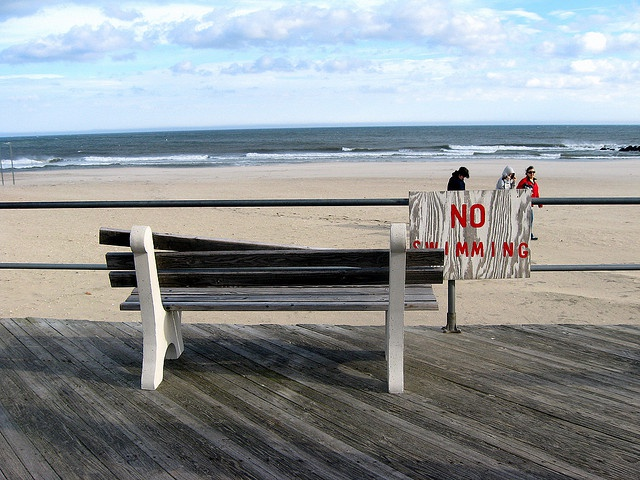Describe the objects in this image and their specific colors. I can see bench in lightblue, black, darkgray, gray, and tan tones, people in lightblue, black, gray, darkgray, and lightgray tones, people in lightblue, gray, darkgray, lightgray, and black tones, and people in lightblue, red, black, maroon, and brown tones in this image. 